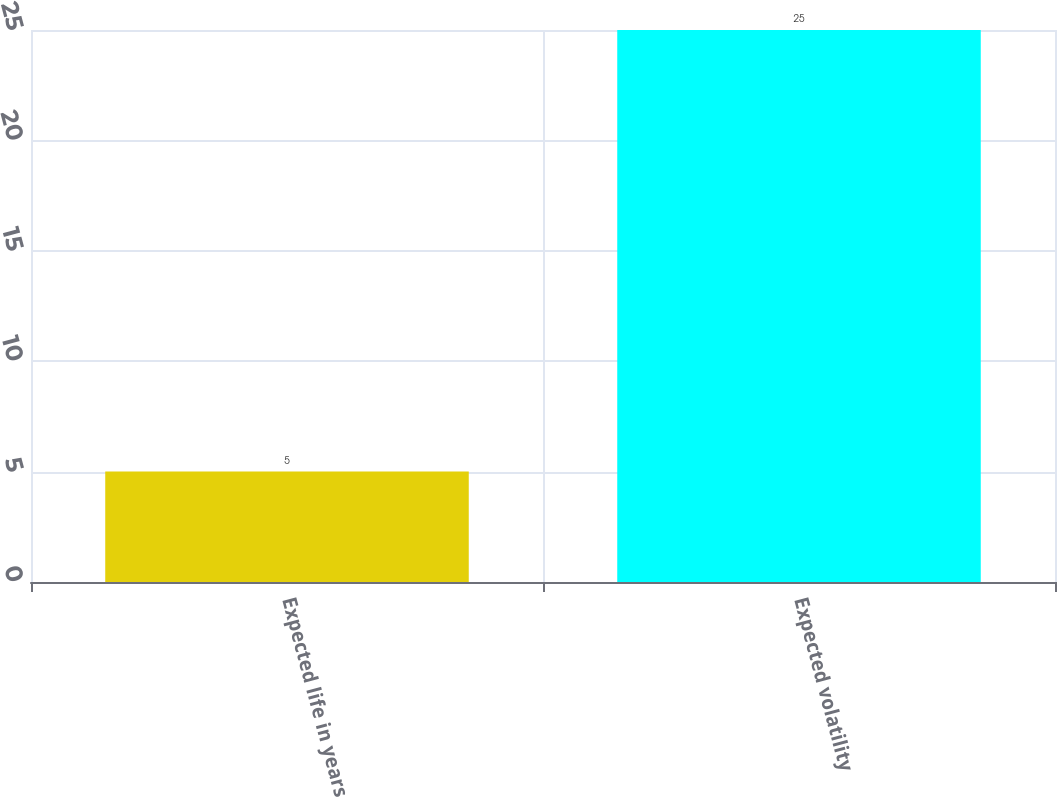<chart> <loc_0><loc_0><loc_500><loc_500><bar_chart><fcel>Expected life in years<fcel>Expected volatility<nl><fcel>5<fcel>25<nl></chart> 